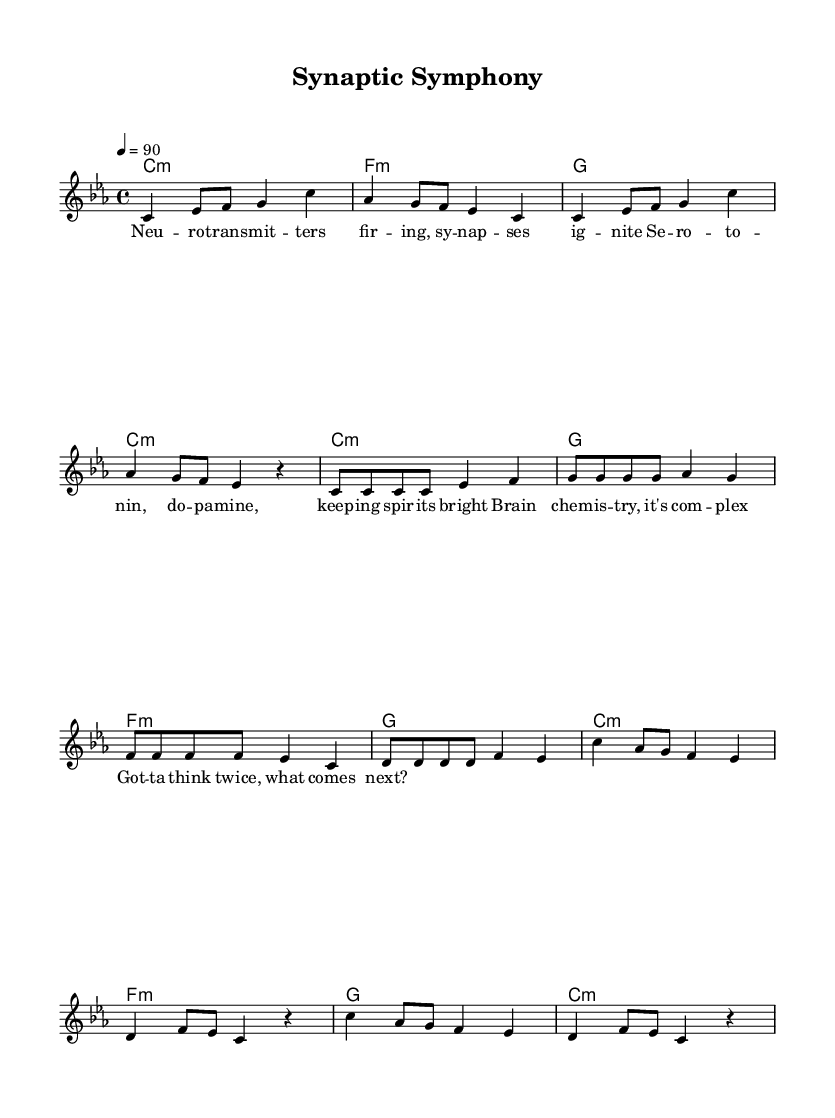What is the key signature of this music? The key signature shows three flat signs, indicating that the piece is in C minor, which has a specific arrangement of notes.
Answer: C minor What is the time signature of this music? The time signature is indicated at the beginning of the score, which is 4/4, meaning there are four beats in each measure and the quarter note gets one beat.
Answer: 4/4 What is the tempo marking of this music? The tempo marking is noted as "4 = 90," which indicates that the speed of the piece is set at 90 beats per minute, specifically for the quarter note.
Answer: 90 How many measures are in the intro section? Counting the measures in the intro, there are four distinct measures present before the verse begins, which is clear from the layout of the notes.
Answer: 4 What is the main theme described in the chorus lyrics? Analyzing the chorus lyrics shows it revolves around the complexity of brain chemistry, emphasizing the need for careful consideration, specifically when phrased in "Got -- ta think twice, what comes next?"
Answer: Brain chemistry How does the melody start in terms of note movement? The melody begins with a series of rising notes followed by repeated tones, observed by analyzing the first few notes in succession that create an upward musical motion.
Answer: Rising notes What unique characteristic defines this as Hip Hop music? The incorporation of rhythm and rhyme in the lyrics combined with a steady beat structure along with the hip hop style's emphasis on verbal delivery highlights its classification as Hip Hop.
Answer: Rhythm and rhyme 